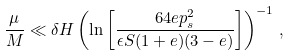Convert formula to latex. <formula><loc_0><loc_0><loc_500><loc_500>\frac { \mu } { M } \ll \delta H \left ( \ln \left [ \frac { 6 4 e p _ { s } ^ { 2 } } { \epsilon S ( 1 + e ) ( 3 - e ) } \right ] \right ) ^ { - 1 } \, ,</formula> 